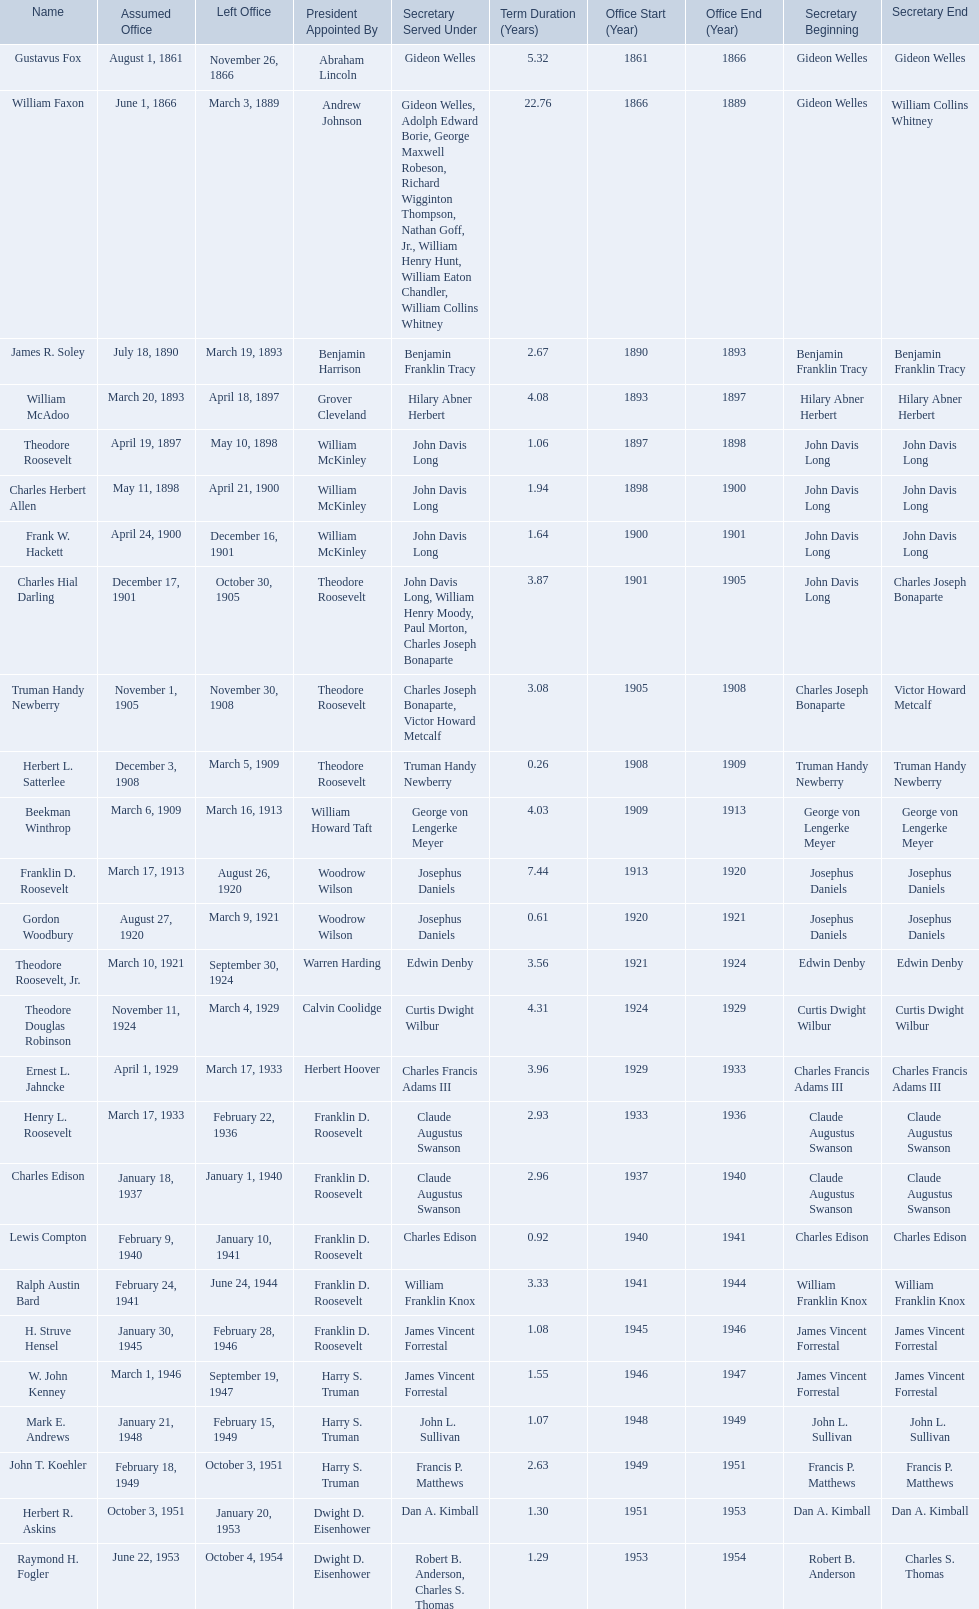What are all the names? Gustavus Fox, William Faxon, James R. Soley, William McAdoo, Theodore Roosevelt, Charles Herbert Allen, Frank W. Hackett, Charles Hial Darling, Truman Handy Newberry, Herbert L. Satterlee, Beekman Winthrop, Franklin D. Roosevelt, Gordon Woodbury, Theodore Roosevelt, Jr., Theodore Douglas Robinson, Ernest L. Jahncke, Henry L. Roosevelt, Charles Edison, Lewis Compton, Ralph Austin Bard, H. Struve Hensel, W. John Kenney, Mark E. Andrews, John T. Koehler, Herbert R. Askins, Raymond H. Fogler. When did they leave office? November 26, 1866, March 3, 1889, March 19, 1893, April 18, 1897, May 10, 1898, April 21, 1900, December 16, 1901, October 30, 1905, November 30, 1908, March 5, 1909, March 16, 1913, August 26, 1920, March 9, 1921, September 30, 1924, March 4, 1929, March 17, 1933, February 22, 1936, January 1, 1940, January 10, 1941, June 24, 1944, February 28, 1946, September 19, 1947, February 15, 1949, October 3, 1951, January 20, 1953, October 4, 1954. And when did raymond h. fogler leave? October 4, 1954. 